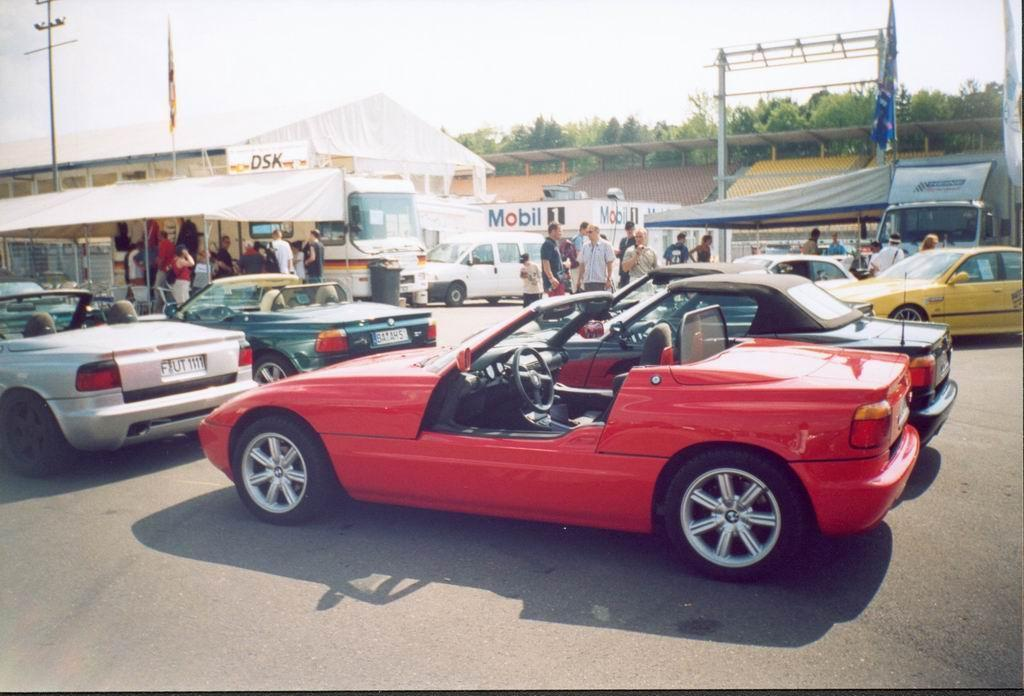What is the main subject of the image? The main subject of the image is many vehicles. What can be seen in the background of the image? In the background of the image, there are many people, tents, buildings, flags, poles, trees, and the sky. How many types of structures are visible in the background? There are at least three types of structures visible in the background: tents, buildings, and poles. What type of mint is being used to flavor the bikes in the image? There are no bikes or mint present in the image; it features many vehicles and various elements in the background. Why are the people in the background of the image crying? There is no indication in the image that the people in the background are crying. 